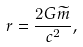Convert formula to latex. <formula><loc_0><loc_0><loc_500><loc_500>r = \frac { 2 G \widetilde { m } } { c ^ { 2 } } ,</formula> 